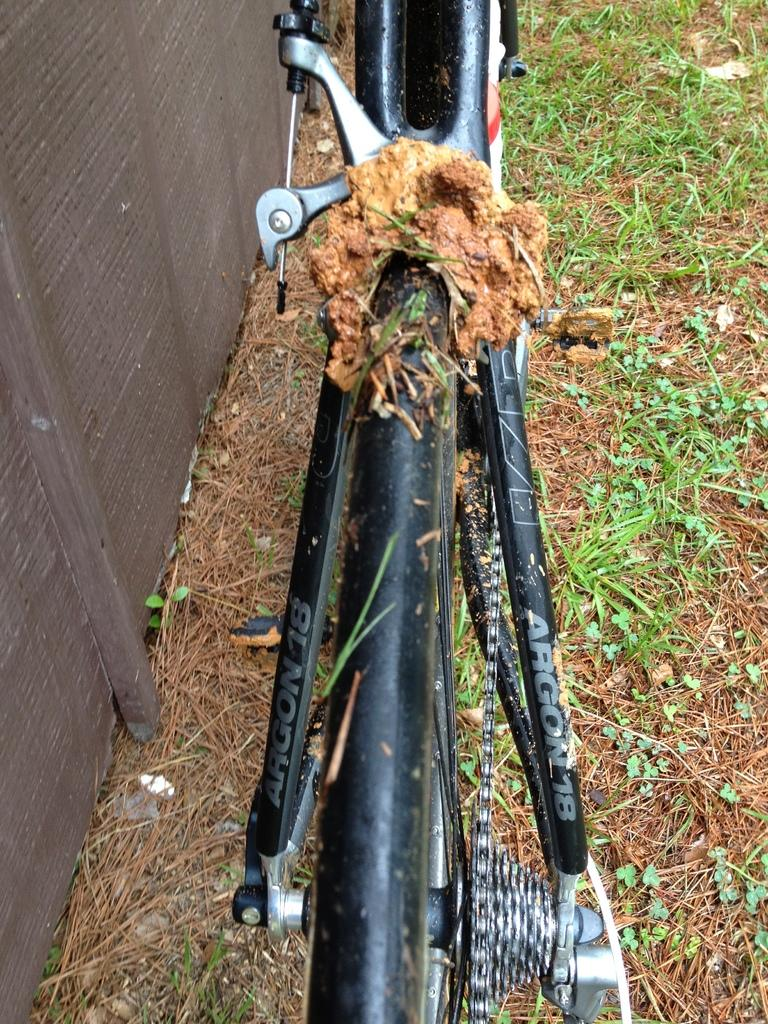What is the main subject in the middle of the picture? There is a bicycle in the middle of the picture. What type of terrain can be seen in the image? There is grass visible on the land. How does the bicycle change its appearance in the image? The bicycle does not change its appearance in the image; it remains the same throughout. 